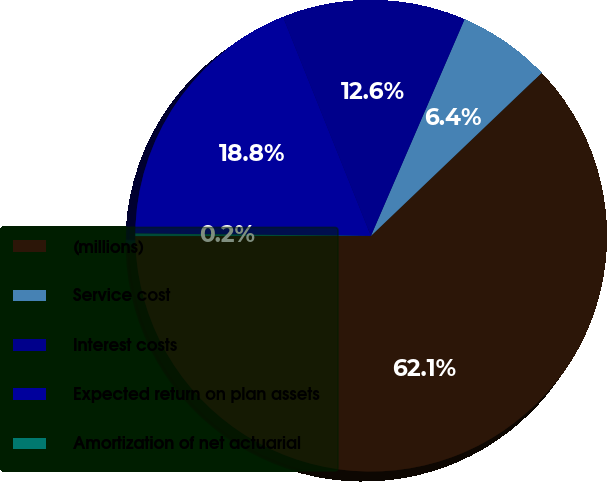<chart> <loc_0><loc_0><loc_500><loc_500><pie_chart><fcel>(millions)<fcel>Service cost<fcel>Interest costs<fcel>Expected return on plan assets<fcel>Amortization of net actuarial<nl><fcel>62.12%<fcel>6.37%<fcel>12.57%<fcel>18.76%<fcel>0.18%<nl></chart> 